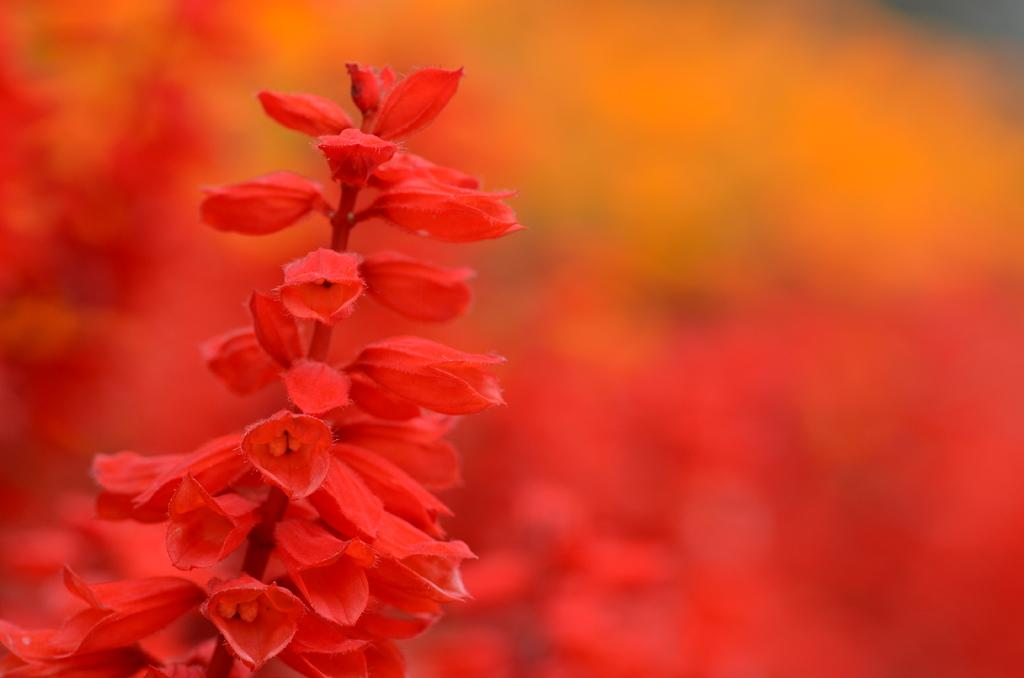What is the main subject of the image? The main subject of the image is a stem. What can be seen on the stem? There are red color flowers on the stem. How would you describe the background of the image? The background of the image is blurred. Can you tell me how many airplanes are flying in the background of the image? There are no airplanes visible in the image; the background is blurred. What type of plant is the stem attached to in the image? The provided facts do not mention any specific plant, only the presence of red color flowers on the stem. 